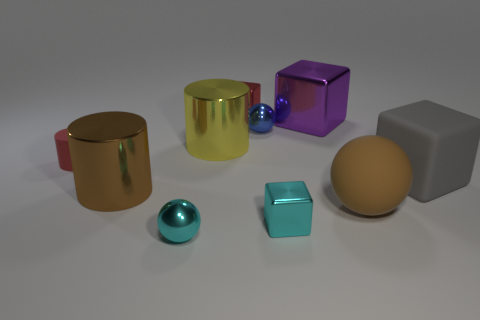Subtract 1 blocks. How many blocks are left? 3 Subtract all blocks. How many objects are left? 6 Add 9 purple metal objects. How many purple metal objects exist? 10 Subtract 0 yellow spheres. How many objects are left? 10 Subtract all spheres. Subtract all brown cylinders. How many objects are left? 6 Add 7 tiny metallic blocks. How many tiny metallic blocks are left? 9 